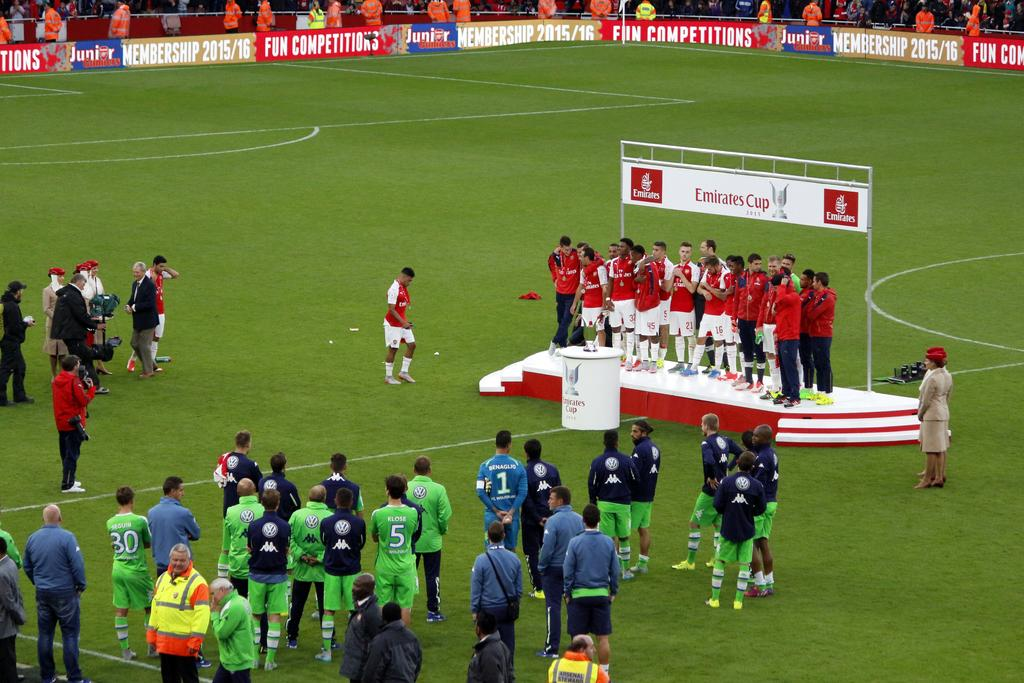Provide a one-sentence caption for the provided image. The victorious team at the Emirates Cup stands on the podium. 